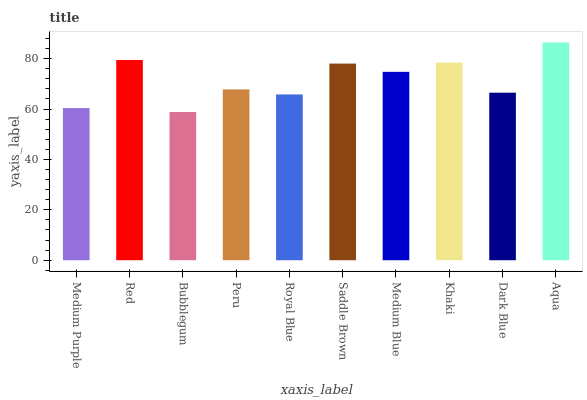Is Red the minimum?
Answer yes or no. No. Is Red the maximum?
Answer yes or no. No. Is Red greater than Medium Purple?
Answer yes or no. Yes. Is Medium Purple less than Red?
Answer yes or no. Yes. Is Medium Purple greater than Red?
Answer yes or no. No. Is Red less than Medium Purple?
Answer yes or no. No. Is Medium Blue the high median?
Answer yes or no. Yes. Is Peru the low median?
Answer yes or no. Yes. Is Saddle Brown the high median?
Answer yes or no. No. Is Medium Blue the low median?
Answer yes or no. No. 